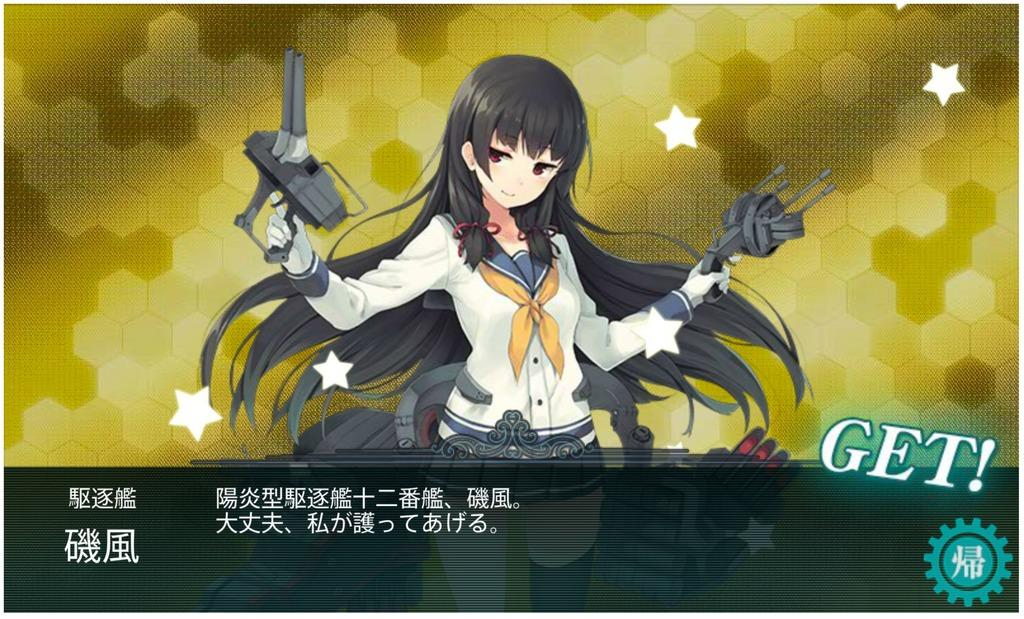What type of image is being described? The image is animated. Can you describe the person in the image? There is a person in the image. What is the person holding in the image? The person is holding an object. Are there any words or letters visible in the image? Yes, there is text visible in the image. What type of songs can be heard in the background of the image? There is no audio or music present in the image, so it's not possible to determine what songs might be heard. 